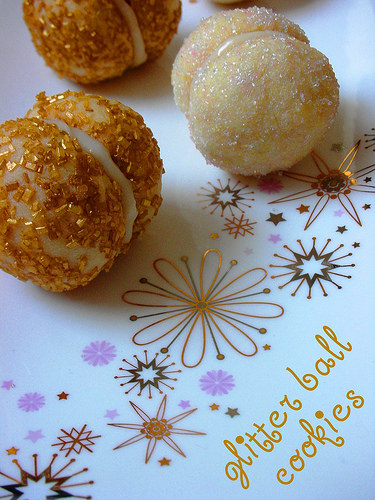<image>
Is the cookies on the table? Yes. Looking at the image, I can see the cookies is positioned on top of the table, with the table providing support. 